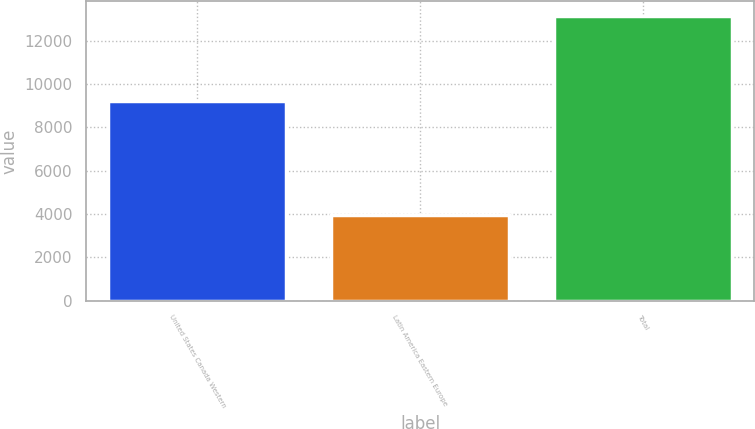Convert chart. <chart><loc_0><loc_0><loc_500><loc_500><bar_chart><fcel>United States Canada Western<fcel>Latin America Eastern Europe<fcel>Total<nl><fcel>9213<fcel>3940<fcel>13153<nl></chart> 